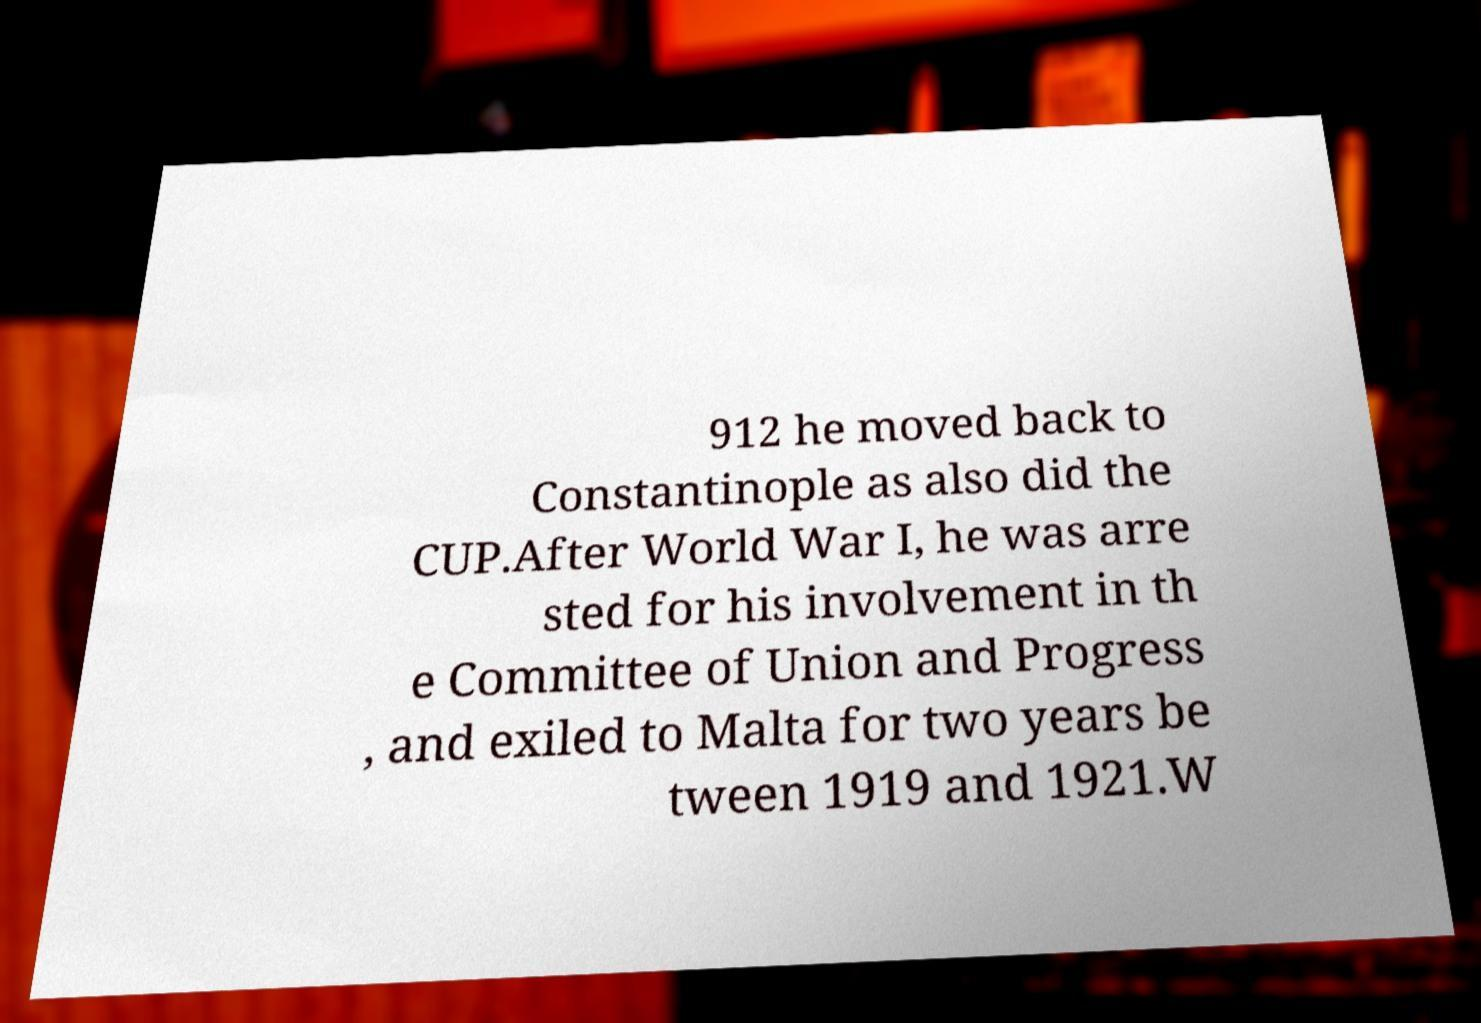I need the written content from this picture converted into text. Can you do that? 912 he moved back to Constantinople as also did the CUP.After World War I, he was arre sted for his involvement in th e Committee of Union and Progress , and exiled to Malta for two years be tween 1919 and 1921.W 